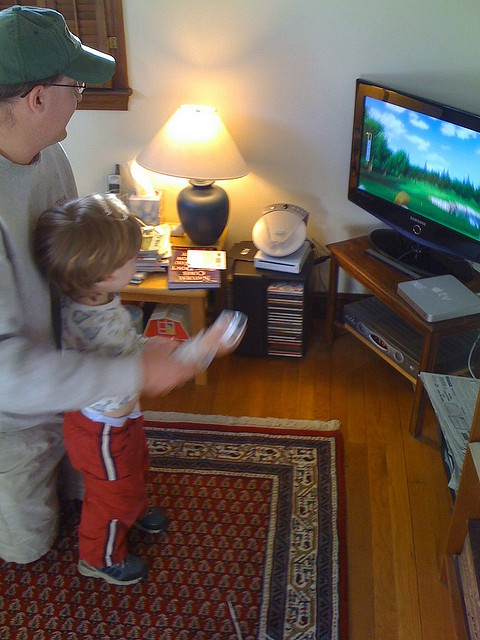Describe the objects in this image and their specific colors. I can see people in black, gray, darkgray, and teal tones, tv in black, teal, and lightblue tones, people in black, gray, and maroon tones, book in black, gray, darkgray, and maroon tones, and book in black, khaki, gray, and beige tones in this image. 